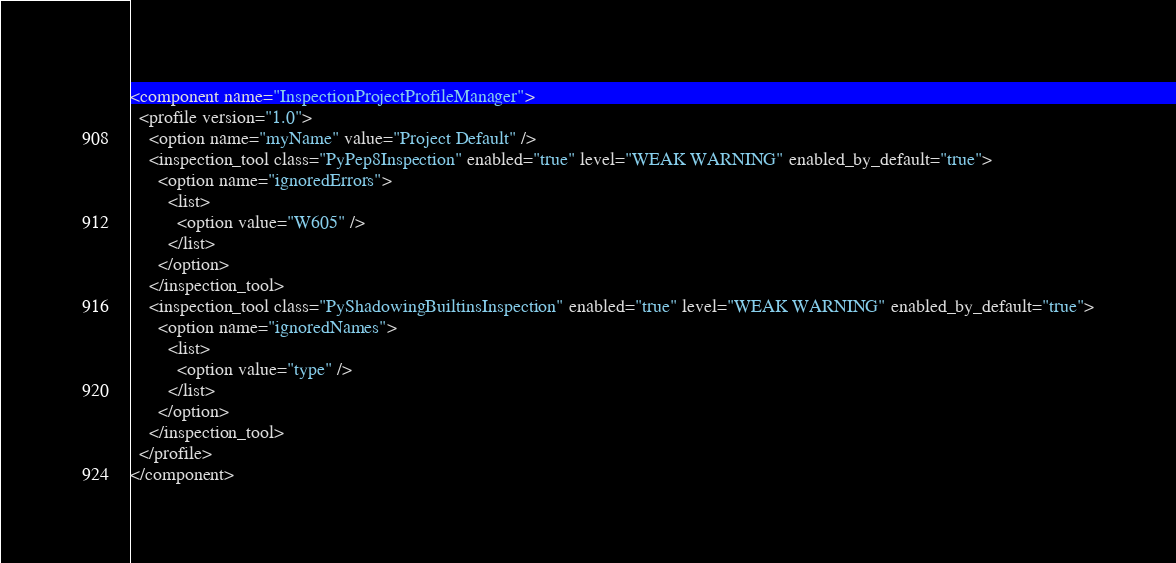Convert code to text. <code><loc_0><loc_0><loc_500><loc_500><_XML_><component name="InspectionProjectProfileManager">
  <profile version="1.0">
    <option name="myName" value="Project Default" />
    <inspection_tool class="PyPep8Inspection" enabled="true" level="WEAK WARNING" enabled_by_default="true">
      <option name="ignoredErrors">
        <list>
          <option value="W605" />
        </list>
      </option>
    </inspection_tool>
    <inspection_tool class="PyShadowingBuiltinsInspection" enabled="true" level="WEAK WARNING" enabled_by_default="true">
      <option name="ignoredNames">
        <list>
          <option value="type" />
        </list>
      </option>
    </inspection_tool>
  </profile>
</component></code> 